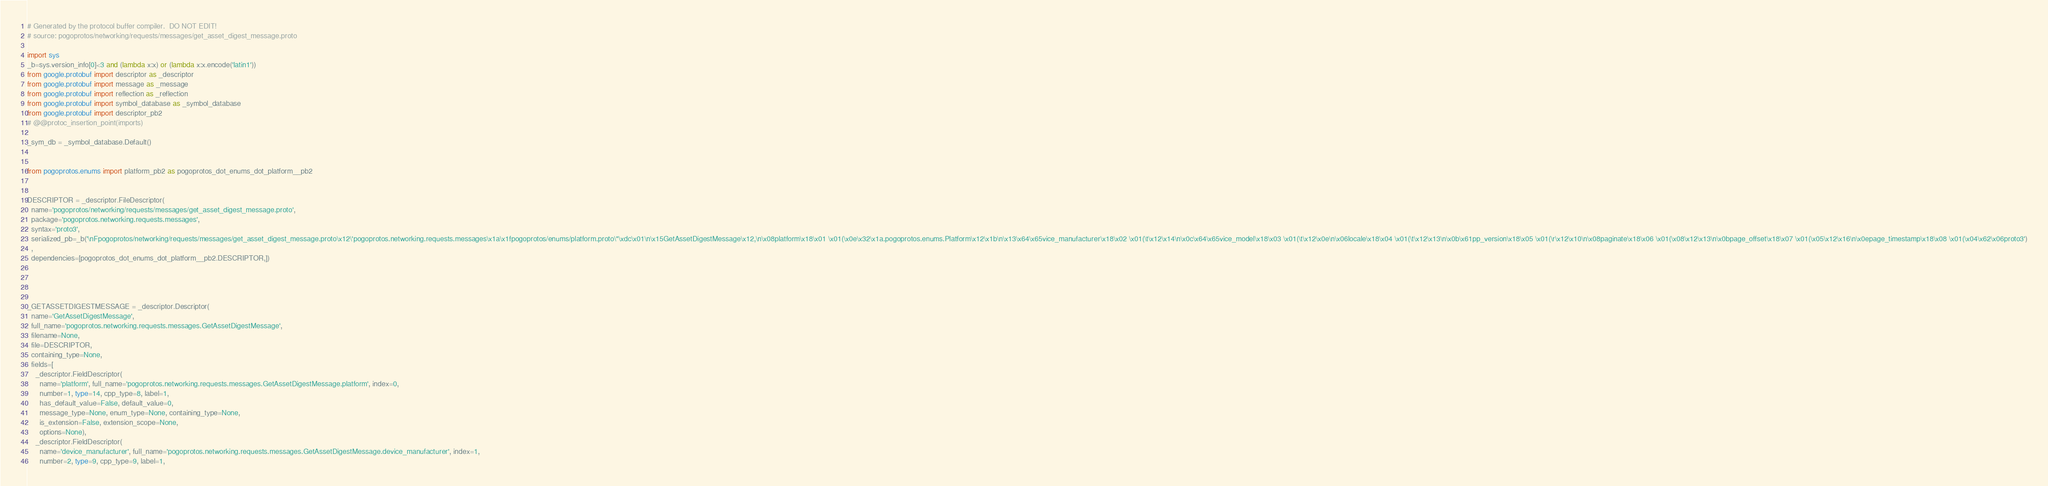Convert code to text. <code><loc_0><loc_0><loc_500><loc_500><_Python_># Generated by the protocol buffer compiler.  DO NOT EDIT!
# source: pogoprotos/networking/requests/messages/get_asset_digest_message.proto

import sys
_b=sys.version_info[0]<3 and (lambda x:x) or (lambda x:x.encode('latin1'))
from google.protobuf import descriptor as _descriptor
from google.protobuf import message as _message
from google.protobuf import reflection as _reflection
from google.protobuf import symbol_database as _symbol_database
from google.protobuf import descriptor_pb2
# @@protoc_insertion_point(imports)

_sym_db = _symbol_database.Default()


from pogoprotos.enums import platform_pb2 as pogoprotos_dot_enums_dot_platform__pb2


DESCRIPTOR = _descriptor.FileDescriptor(
  name='pogoprotos/networking/requests/messages/get_asset_digest_message.proto',
  package='pogoprotos.networking.requests.messages',
  syntax='proto3',
  serialized_pb=_b('\nFpogoprotos/networking/requests/messages/get_asset_digest_message.proto\x12\'pogoprotos.networking.requests.messages\x1a\x1fpogoprotos/enums/platform.proto\"\xdc\x01\n\x15GetAssetDigestMessage\x12,\n\x08platform\x18\x01 \x01(\x0e\x32\x1a.pogoprotos.enums.Platform\x12\x1b\n\x13\x64\x65vice_manufacturer\x18\x02 \x01(\t\x12\x14\n\x0c\x64\x65vice_model\x18\x03 \x01(\t\x12\x0e\n\x06locale\x18\x04 \x01(\t\x12\x13\n\x0b\x61pp_version\x18\x05 \x01(\r\x12\x10\n\x08paginate\x18\x06 \x01(\x08\x12\x13\n\x0bpage_offset\x18\x07 \x01(\x05\x12\x16\n\x0epage_timestamp\x18\x08 \x01(\x04\x62\x06proto3')
  ,
  dependencies=[pogoprotos_dot_enums_dot_platform__pb2.DESCRIPTOR,])




_GETASSETDIGESTMESSAGE = _descriptor.Descriptor(
  name='GetAssetDigestMessage',
  full_name='pogoprotos.networking.requests.messages.GetAssetDigestMessage',
  filename=None,
  file=DESCRIPTOR,
  containing_type=None,
  fields=[
    _descriptor.FieldDescriptor(
      name='platform', full_name='pogoprotos.networking.requests.messages.GetAssetDigestMessage.platform', index=0,
      number=1, type=14, cpp_type=8, label=1,
      has_default_value=False, default_value=0,
      message_type=None, enum_type=None, containing_type=None,
      is_extension=False, extension_scope=None,
      options=None),
    _descriptor.FieldDescriptor(
      name='device_manufacturer', full_name='pogoprotos.networking.requests.messages.GetAssetDigestMessage.device_manufacturer', index=1,
      number=2, type=9, cpp_type=9, label=1,</code> 